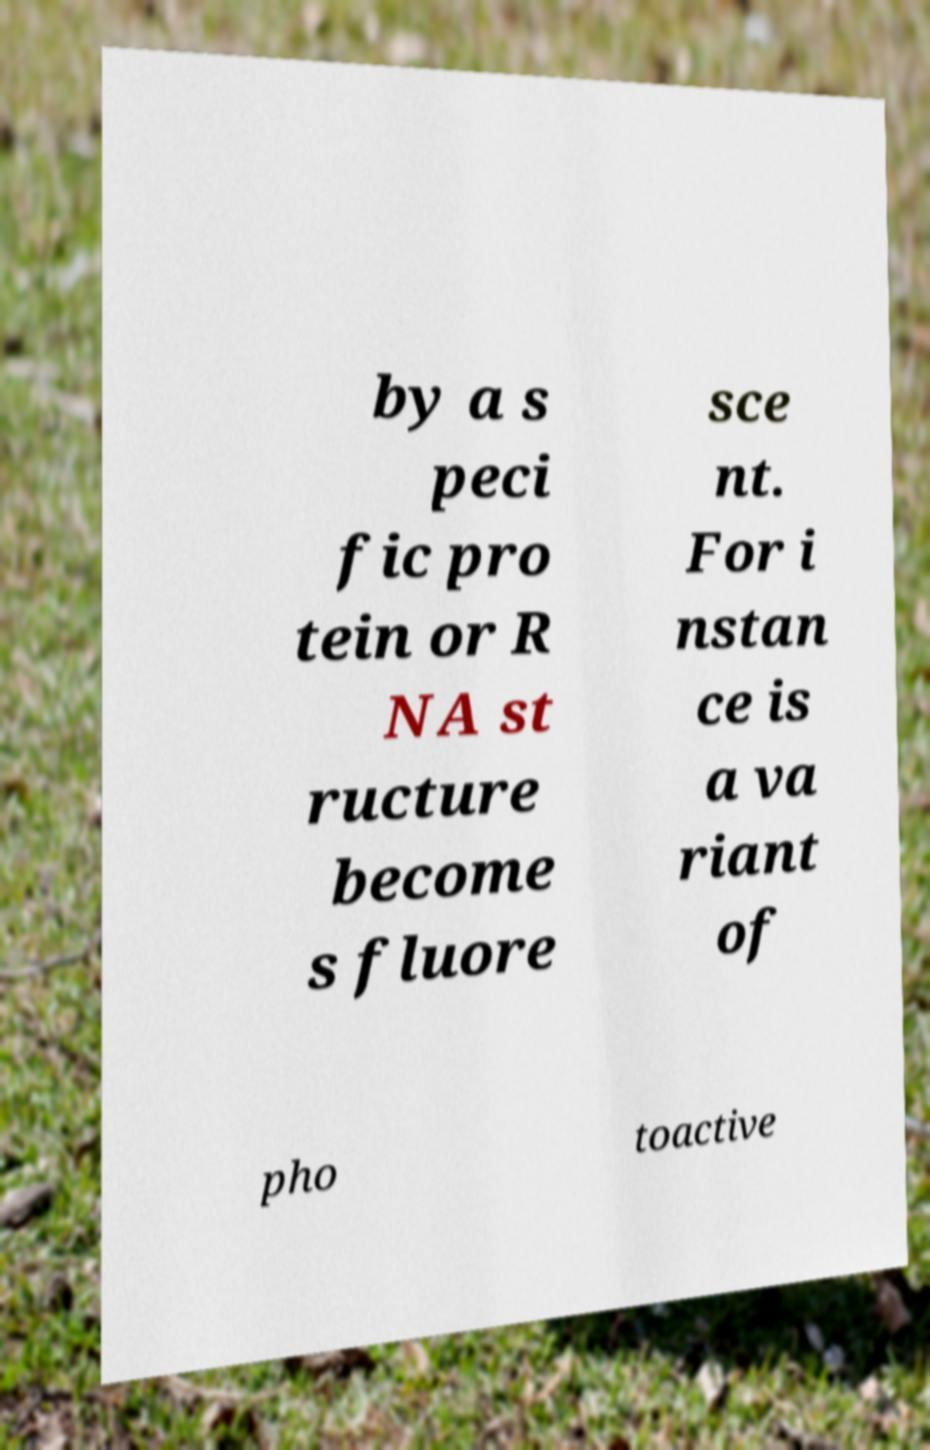Could you extract and type out the text from this image? by a s peci fic pro tein or R NA st ructure become s fluore sce nt. For i nstan ce is a va riant of pho toactive 